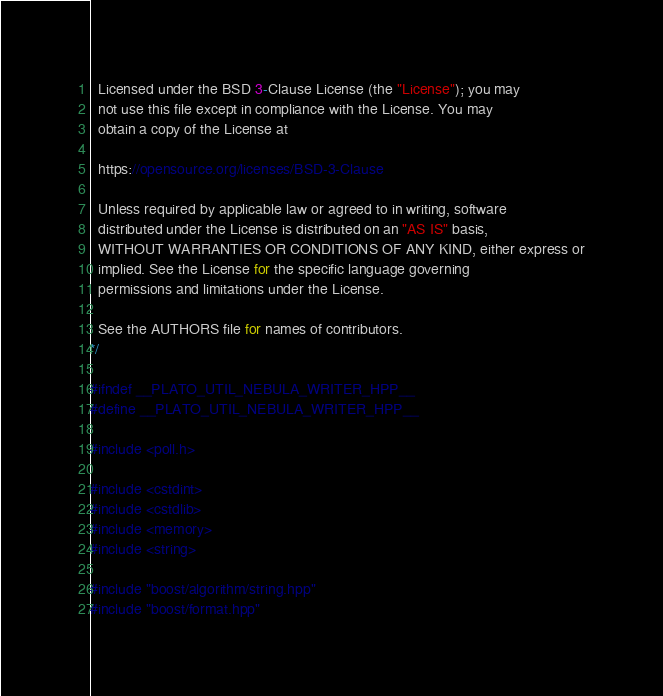<code> <loc_0><loc_0><loc_500><loc_500><_C_>
  Licensed under the BSD 3-Clause License (the "License"); you may
  not use this file except in compliance with the License. You may
  obtain a copy of the License at

  https://opensource.org/licenses/BSD-3-Clause

  Unless required by applicable law or agreed to in writing, software
  distributed under the License is distributed on an "AS IS" basis,
  WITHOUT WARRANTIES OR CONDITIONS OF ANY KIND, either express or
  implied. See the License for the specific language governing
  permissions and limitations under the License.

  See the AUTHORS file for names of contributors.
*/

#ifndef __PLATO_UTIL_NEBULA_WRITER_HPP__
#define __PLATO_UTIL_NEBULA_WRITER_HPP__

#include <poll.h>

#include <cstdint>
#include <cstdlib>
#include <memory>
#include <string>

#include "boost/algorithm/string.hpp"
#include "boost/format.hpp"</code> 